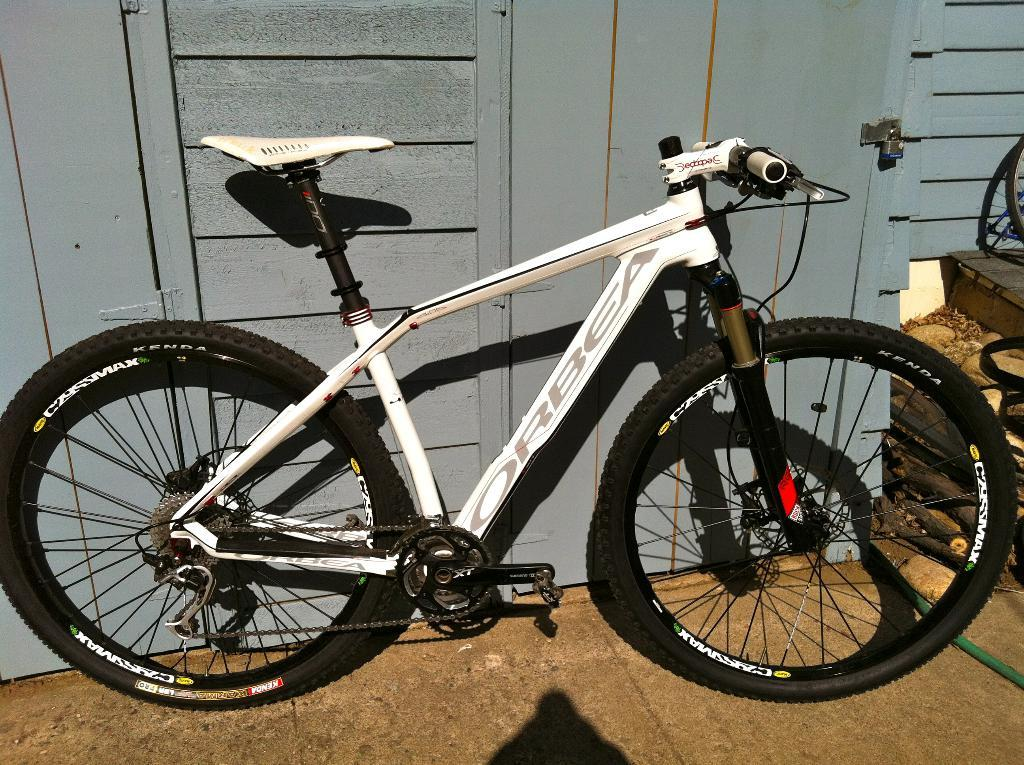What type of bicycle is in the image? There is a white and black wheel bicycle in the image. Where is the bicycle located in relation to the surroundings? The bicycle is parked in the front. What can be seen in the background of the image? There is a grey color door visible in the background of the image. What type of pickle is on the plate next to the bicycle in the image? There is no plate or pickle present in the image; it only features a bicycle and a grey color door in the background. 